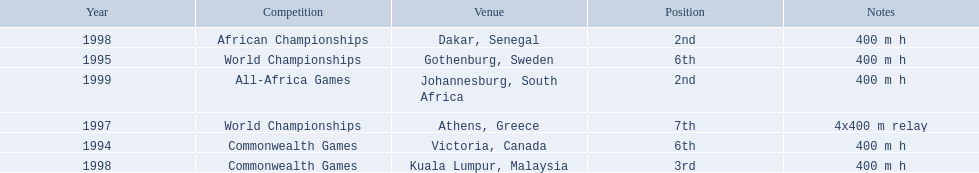What races did ken harden run? 400 m h, 400 m h, 4x400 m relay, 400 m h, 400 m h, 400 m h. Which race did ken harden run in 1997? 4x400 m relay. 